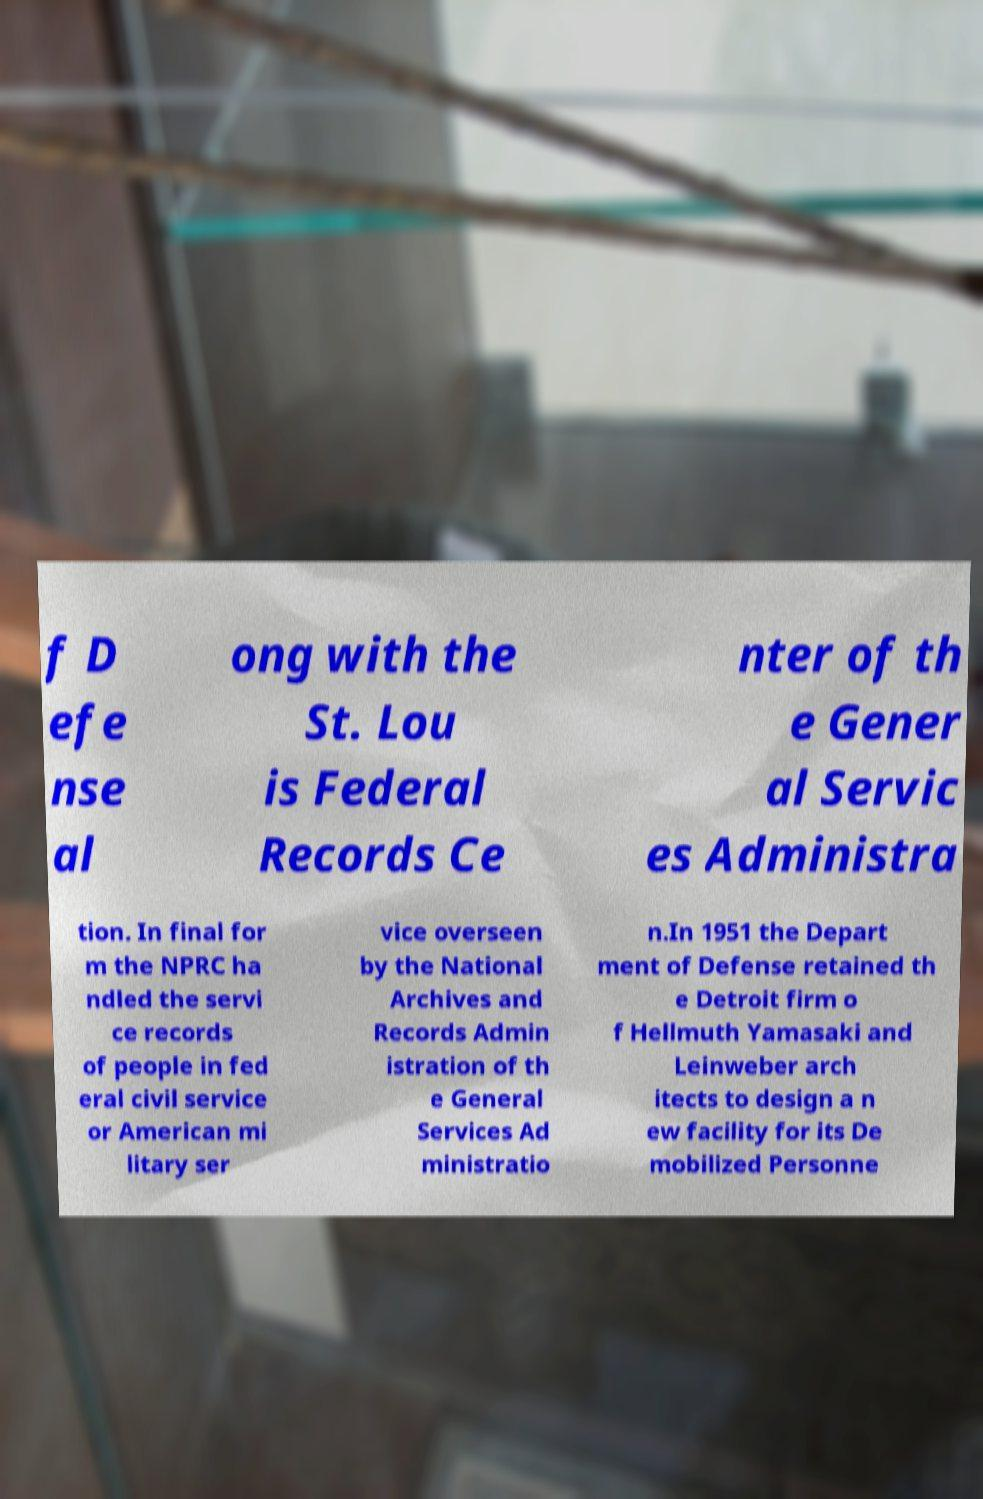Please identify and transcribe the text found in this image. f D efe nse al ong with the St. Lou is Federal Records Ce nter of th e Gener al Servic es Administra tion. In final for m the NPRC ha ndled the servi ce records of people in fed eral civil service or American mi litary ser vice overseen by the National Archives and Records Admin istration of th e General Services Ad ministratio n.In 1951 the Depart ment of Defense retained th e Detroit firm o f Hellmuth Yamasaki and Leinweber arch itects to design a n ew facility for its De mobilized Personne 